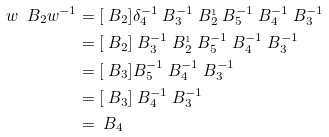Convert formula to latex. <formula><loc_0><loc_0><loc_500><loc_500>w \ B _ { 2 } w ^ { - 1 } & = [ \ B _ { 2 } ] \delta _ { 4 } ^ { - 1 } \ B _ { 3 } ^ { - 1 } \ B _ { 2 } ^ { _ { 1 } } \ B _ { 5 } ^ { - 1 } \ B _ { 4 } ^ { - 1 } \ B _ { 3 } ^ { - 1 } \\ & = [ \ B _ { 2 } ] \ B _ { 3 } ^ { - 1 } \ B _ { 2 } ^ { _ { 1 } } \ B _ { 5 } ^ { - 1 } \ B _ { 4 } ^ { - 1 } \ B _ { 3 } ^ { - 1 } \\ & = [ \ B _ { 3 } ] B _ { 5 } ^ { - 1 } \ B _ { 4 } ^ { - 1 } \ B _ { 3 } ^ { - 1 } \\ & = [ \ B _ { 3 } ] \ B _ { 4 } ^ { - 1 } \ B _ { 3 } ^ { - 1 } \\ & = \ B _ { 4 }</formula> 